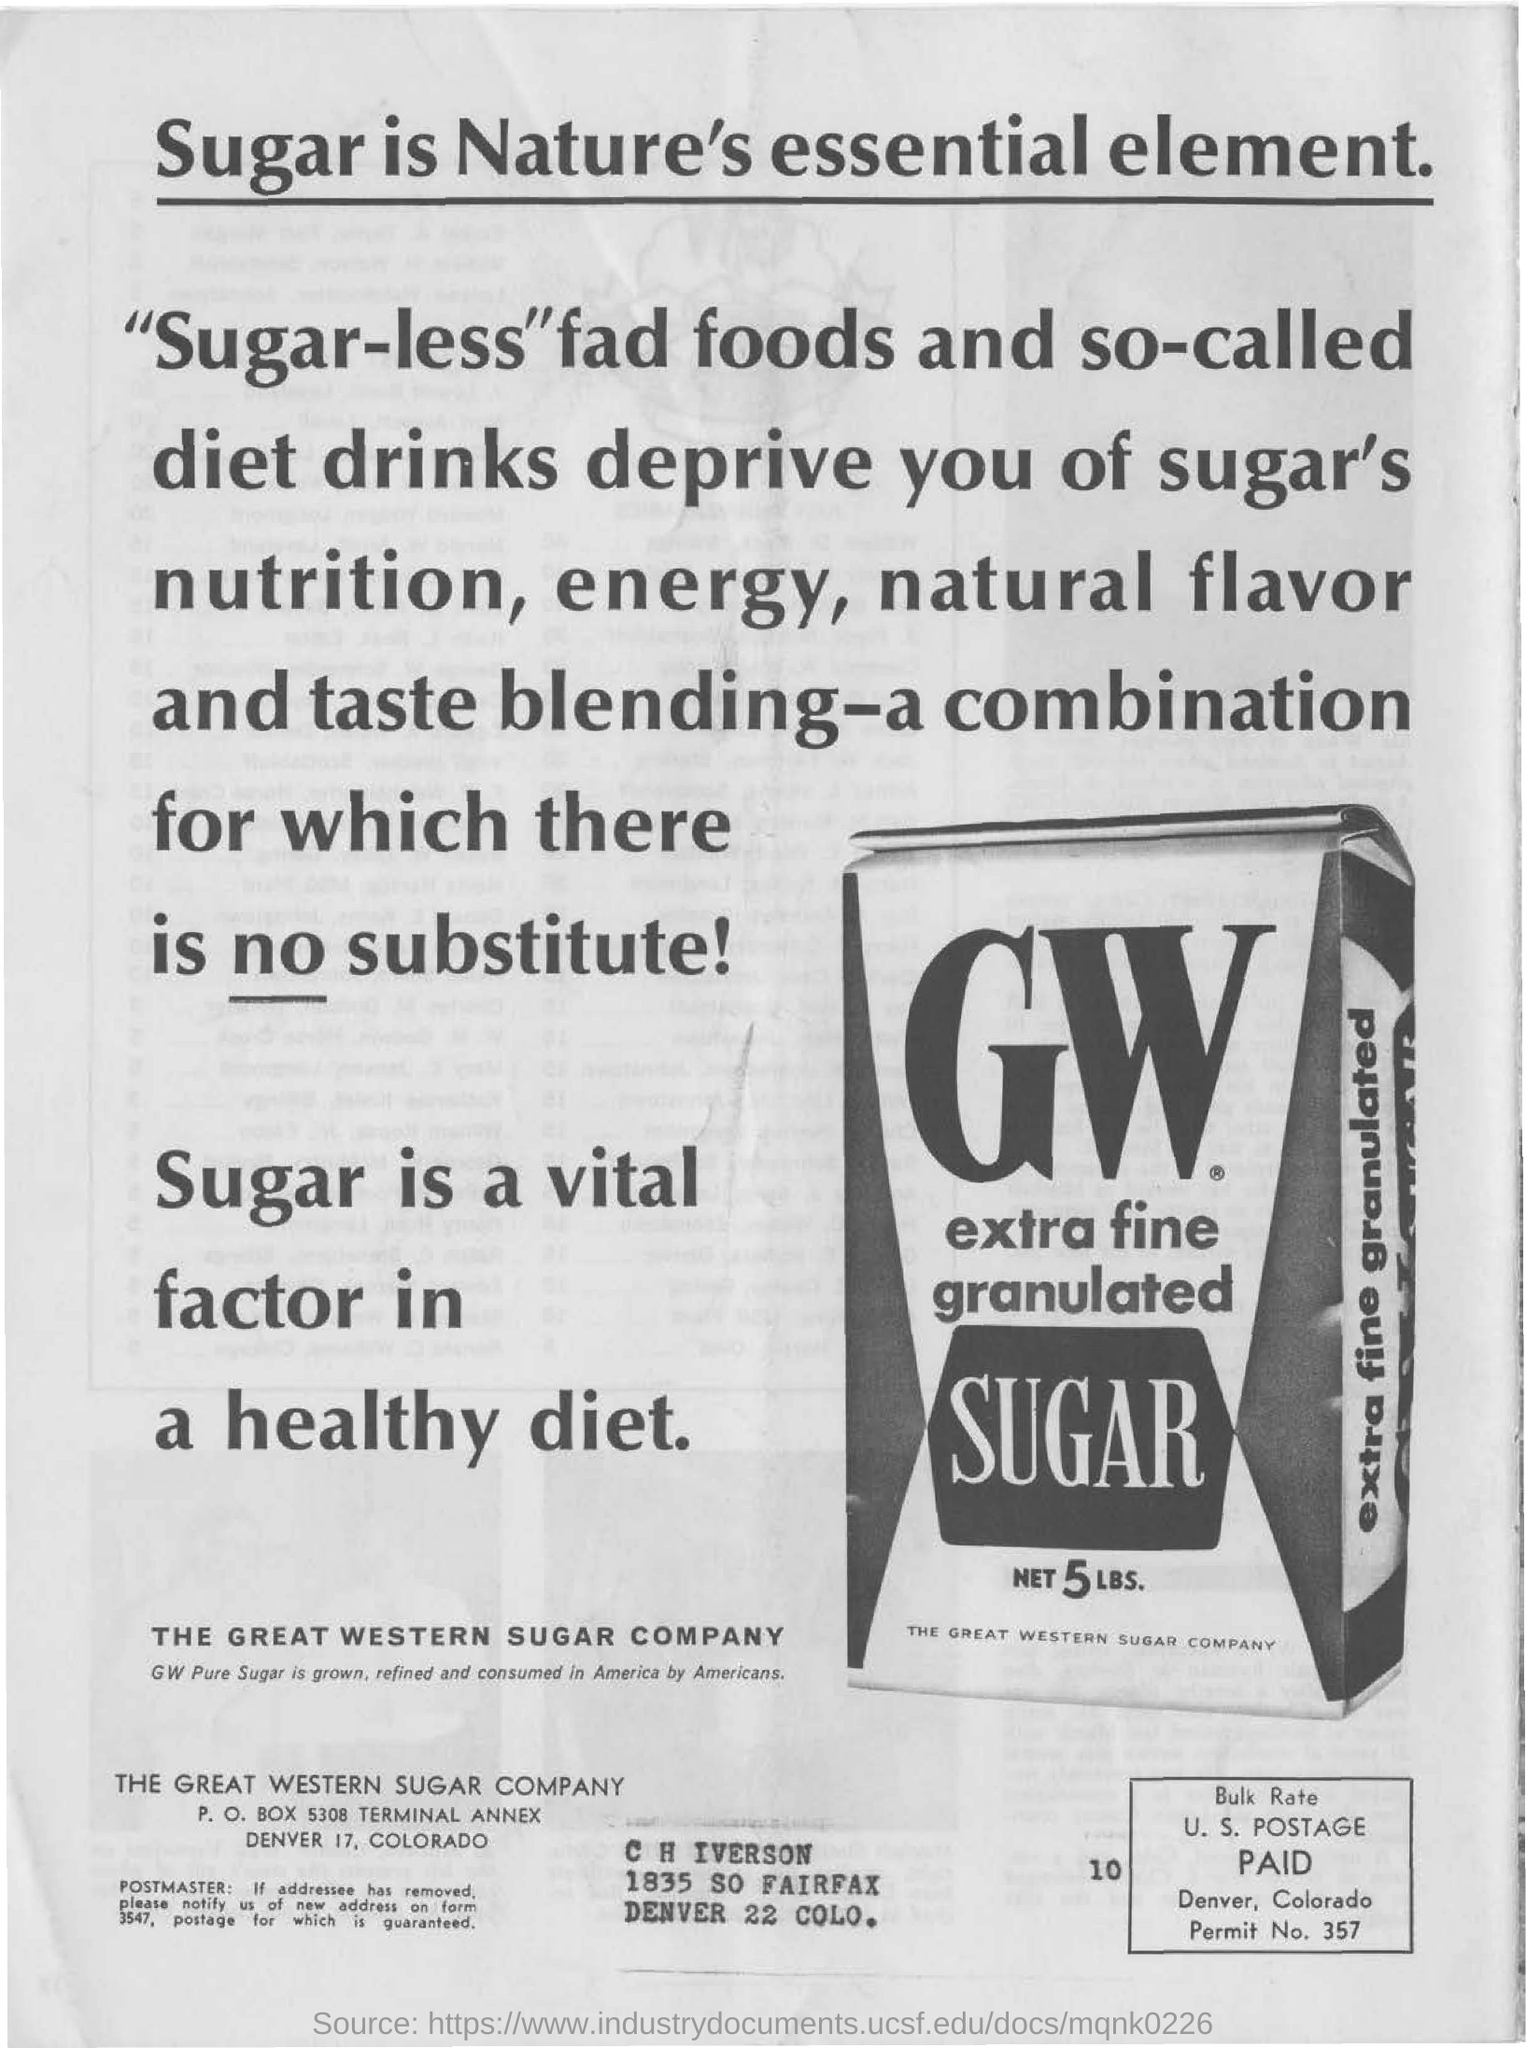List a handful of essential elements in this visual. The net amount of sugar is 5 pounds. The image depicts a product that is a type of granulated sugar, specifically extra fine granulated sugar. The great western sugar company is the name of the sugar company. 